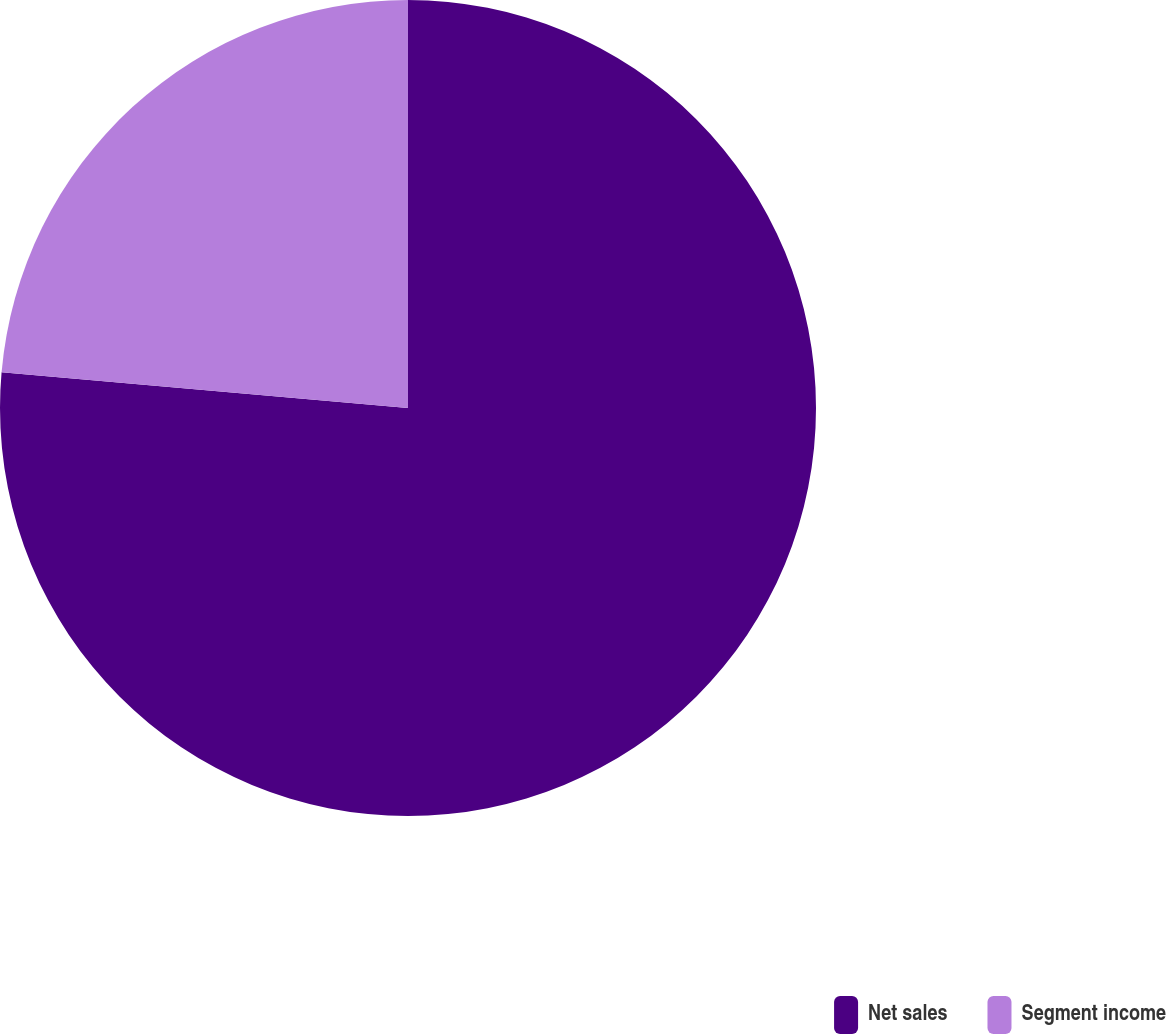Convert chart to OTSL. <chart><loc_0><loc_0><loc_500><loc_500><pie_chart><fcel>Net sales<fcel>Segment income<nl><fcel>76.4%<fcel>23.6%<nl></chart> 